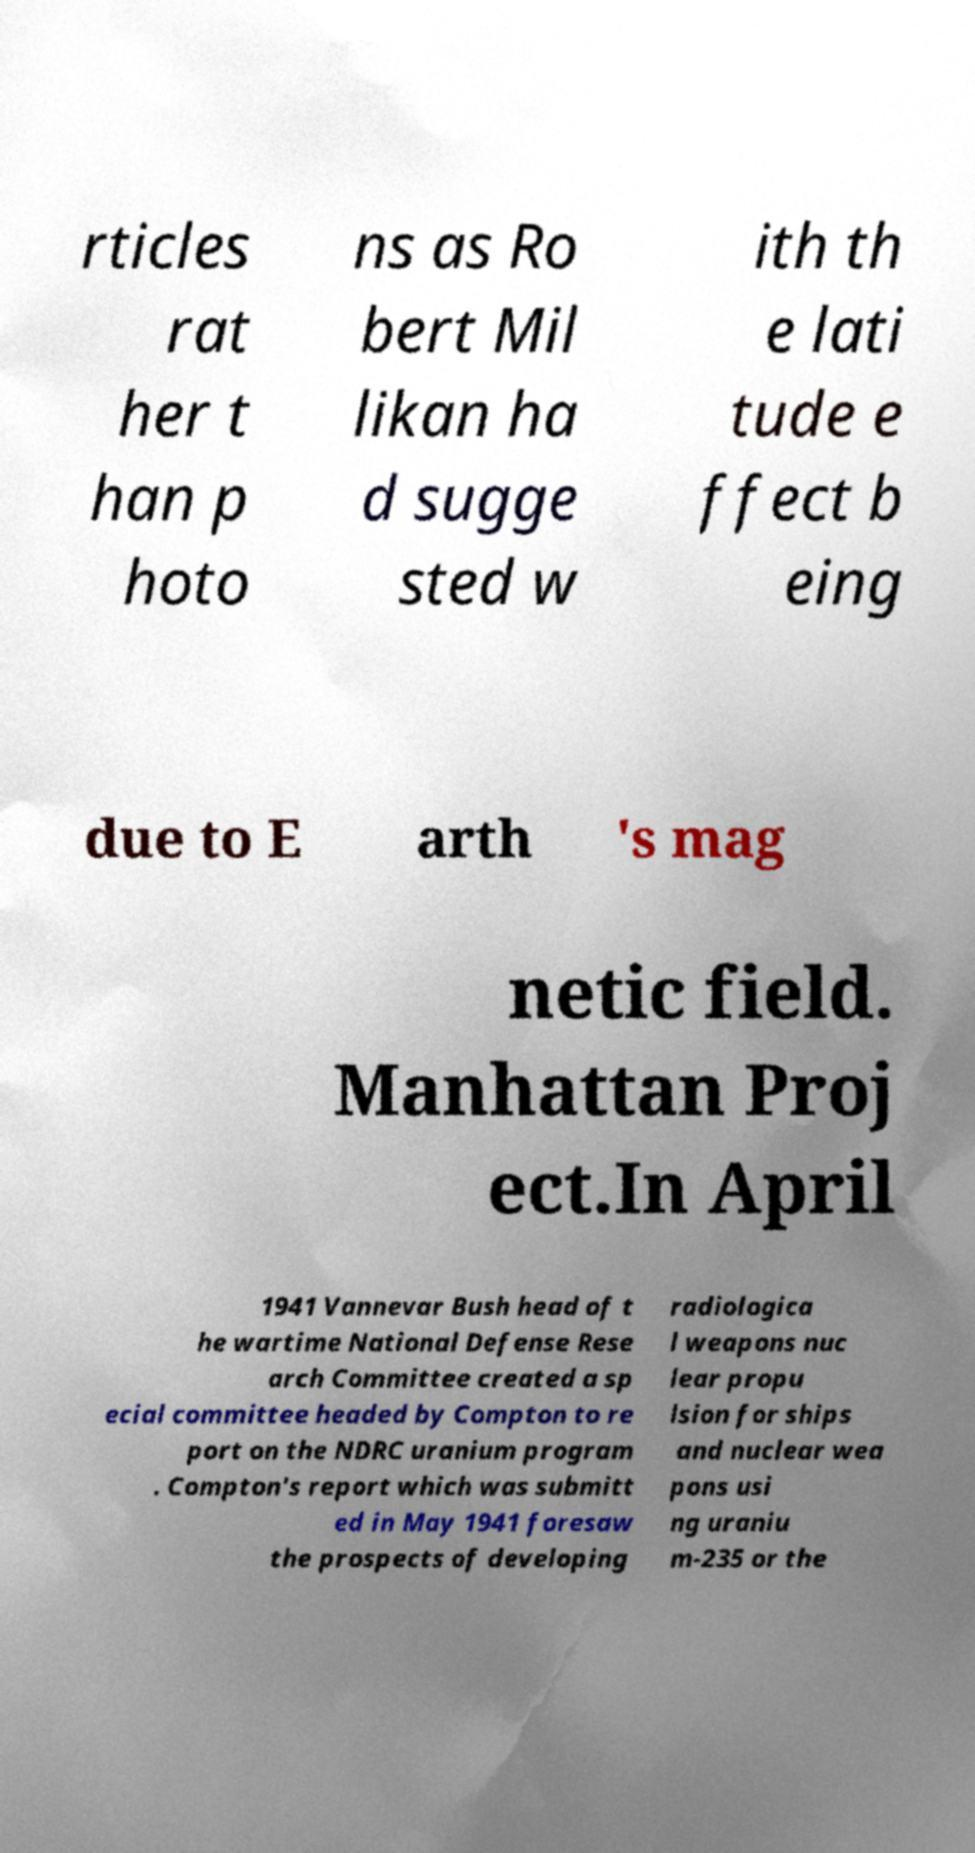Could you assist in decoding the text presented in this image and type it out clearly? rticles rat her t han p hoto ns as Ro bert Mil likan ha d sugge sted w ith th e lati tude e ffect b eing due to E arth 's mag netic field. Manhattan Proj ect.In April 1941 Vannevar Bush head of t he wartime National Defense Rese arch Committee created a sp ecial committee headed by Compton to re port on the NDRC uranium program . Compton's report which was submitt ed in May 1941 foresaw the prospects of developing radiologica l weapons nuc lear propu lsion for ships and nuclear wea pons usi ng uraniu m-235 or the 